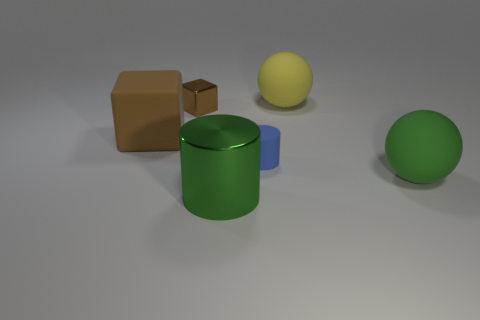There is a large matte object to the left of the large yellow thing; is it the same shape as the big metallic object?
Ensure brevity in your answer.  No. The green object left of the matte ball in front of the tiny brown metallic cube is what shape?
Your response must be concise. Cylinder. Is there anything else that is the same shape as the small metallic thing?
Provide a short and direct response. Yes. There is a big thing that is the same shape as the tiny blue object; what is its color?
Keep it short and to the point. Green. Does the large metallic object have the same color as the ball behind the blue rubber thing?
Your response must be concise. No. What is the shape of the big object that is both behind the big green ball and right of the blue cylinder?
Give a very brief answer. Sphere. Is the number of big green metal cylinders less than the number of tiny green shiny objects?
Ensure brevity in your answer.  No. Are there any balls?
Provide a short and direct response. Yes. How many other objects are the same size as the rubber cylinder?
Your answer should be very brief. 1. Are the small brown block and the small thing on the right side of the brown metallic thing made of the same material?
Provide a short and direct response. No. 